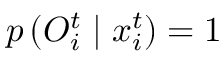<formula> <loc_0><loc_0><loc_500><loc_500>p \left ( O _ { i } ^ { t } | x _ { i } ^ { t } \right ) = 1</formula> 